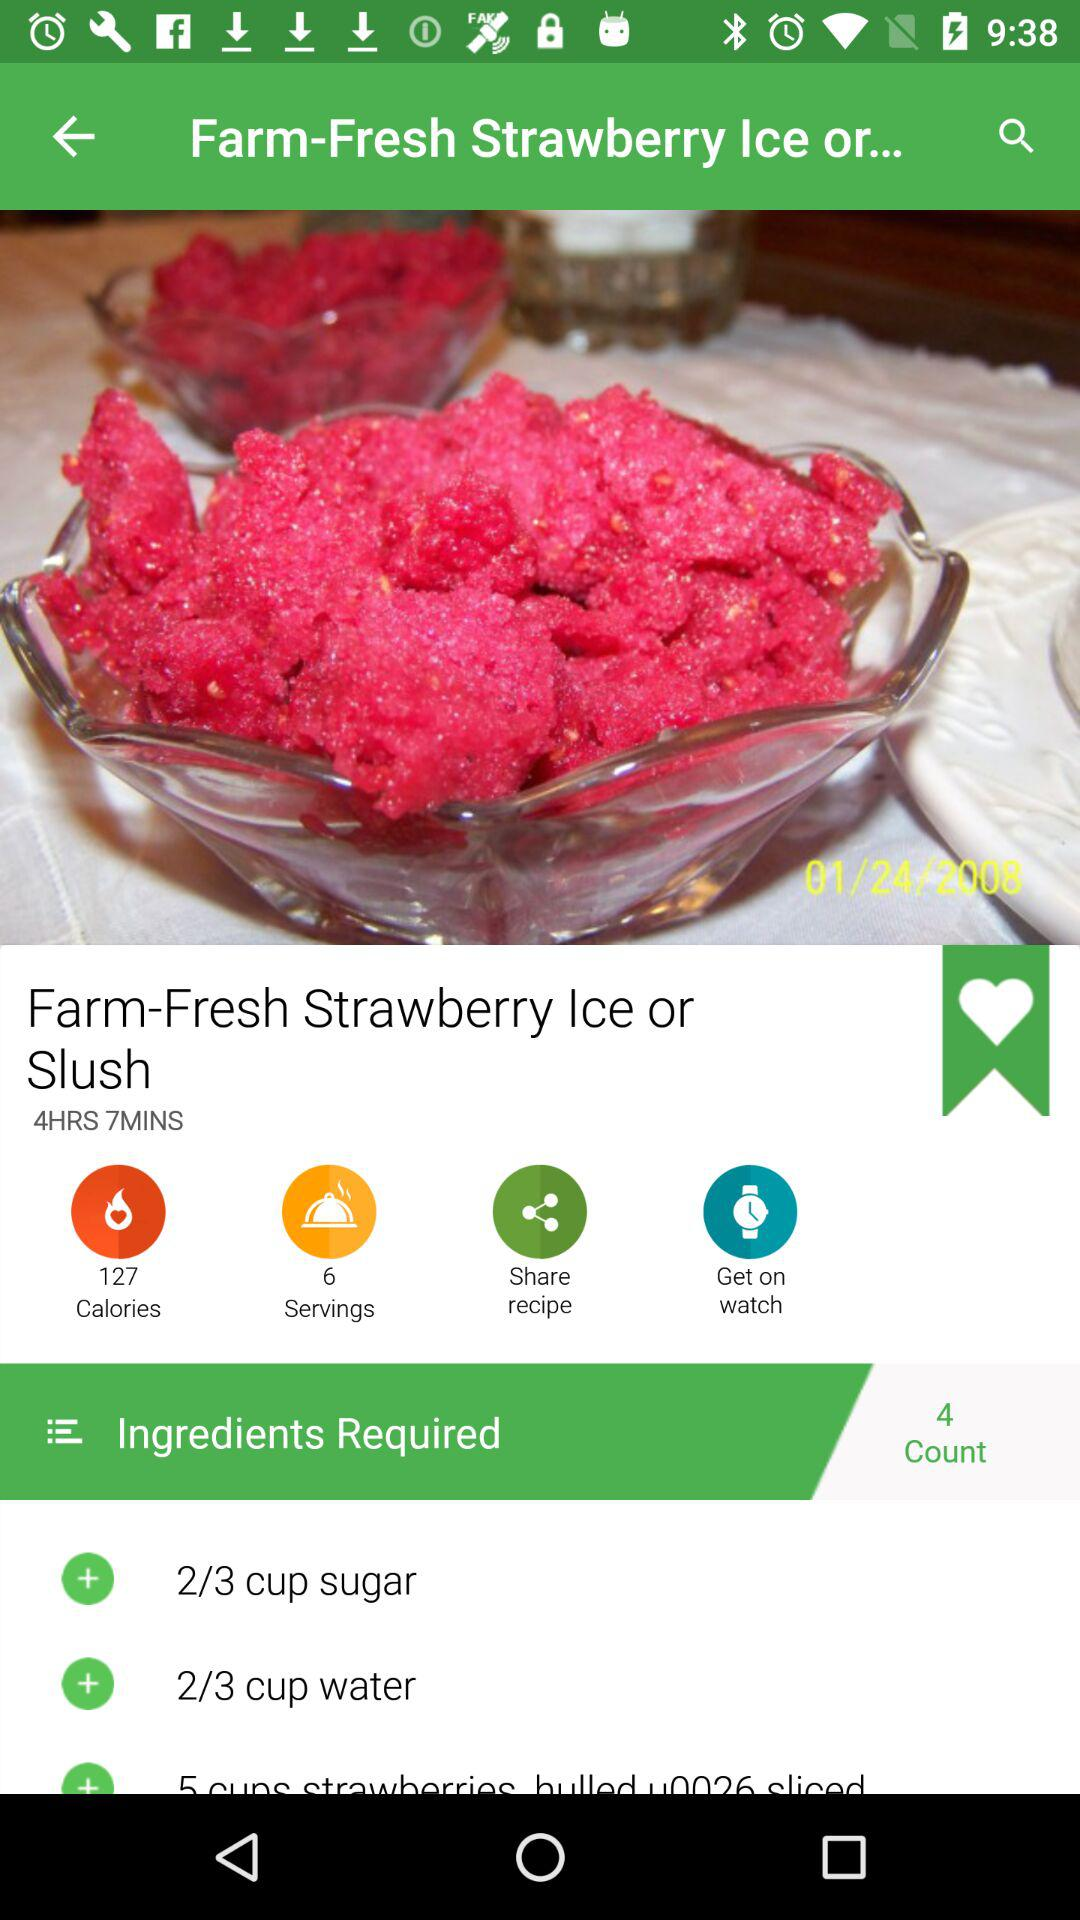How many calories are in the dish? There are 127 calories in the dish. 